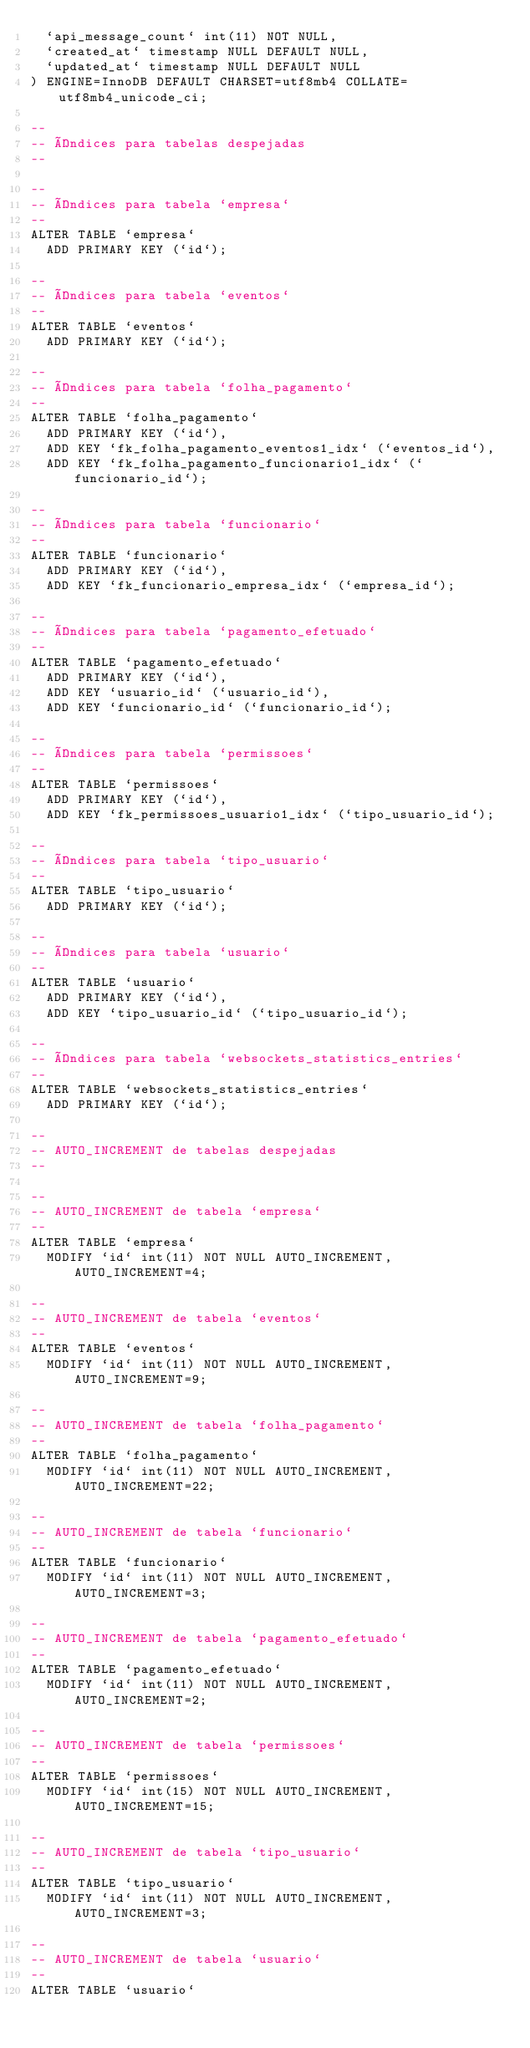<code> <loc_0><loc_0><loc_500><loc_500><_SQL_>  `api_message_count` int(11) NOT NULL,
  `created_at` timestamp NULL DEFAULT NULL,
  `updated_at` timestamp NULL DEFAULT NULL
) ENGINE=InnoDB DEFAULT CHARSET=utf8mb4 COLLATE=utf8mb4_unicode_ci;

--
-- Índices para tabelas despejadas
--

--
-- Índices para tabela `empresa`
--
ALTER TABLE `empresa`
  ADD PRIMARY KEY (`id`);

--
-- Índices para tabela `eventos`
--
ALTER TABLE `eventos`
  ADD PRIMARY KEY (`id`);

--
-- Índices para tabela `folha_pagamento`
--
ALTER TABLE `folha_pagamento`
  ADD PRIMARY KEY (`id`),
  ADD KEY `fk_folha_pagamento_eventos1_idx` (`eventos_id`),
  ADD KEY `fk_folha_pagamento_funcionario1_idx` (`funcionario_id`);

--
-- Índices para tabela `funcionario`
--
ALTER TABLE `funcionario`
  ADD PRIMARY KEY (`id`),
  ADD KEY `fk_funcionario_empresa_idx` (`empresa_id`);

--
-- Índices para tabela `pagamento_efetuado`
--
ALTER TABLE `pagamento_efetuado`
  ADD PRIMARY KEY (`id`),
  ADD KEY `usuario_id` (`usuario_id`),
  ADD KEY `funcionario_id` (`funcionario_id`);

--
-- Índices para tabela `permissoes`
--
ALTER TABLE `permissoes`
  ADD PRIMARY KEY (`id`),
  ADD KEY `fk_permissoes_usuario1_idx` (`tipo_usuario_id`);

--
-- Índices para tabela `tipo_usuario`
--
ALTER TABLE `tipo_usuario`
  ADD PRIMARY KEY (`id`);

--
-- Índices para tabela `usuario`
--
ALTER TABLE `usuario`
  ADD PRIMARY KEY (`id`),
  ADD KEY `tipo_usuario_id` (`tipo_usuario_id`);

--
-- Índices para tabela `websockets_statistics_entries`
--
ALTER TABLE `websockets_statistics_entries`
  ADD PRIMARY KEY (`id`);

--
-- AUTO_INCREMENT de tabelas despejadas
--

--
-- AUTO_INCREMENT de tabela `empresa`
--
ALTER TABLE `empresa`
  MODIFY `id` int(11) NOT NULL AUTO_INCREMENT, AUTO_INCREMENT=4;

--
-- AUTO_INCREMENT de tabela `eventos`
--
ALTER TABLE `eventos`
  MODIFY `id` int(11) NOT NULL AUTO_INCREMENT, AUTO_INCREMENT=9;

--
-- AUTO_INCREMENT de tabela `folha_pagamento`
--
ALTER TABLE `folha_pagamento`
  MODIFY `id` int(11) NOT NULL AUTO_INCREMENT, AUTO_INCREMENT=22;

--
-- AUTO_INCREMENT de tabela `funcionario`
--
ALTER TABLE `funcionario`
  MODIFY `id` int(11) NOT NULL AUTO_INCREMENT, AUTO_INCREMENT=3;

--
-- AUTO_INCREMENT de tabela `pagamento_efetuado`
--
ALTER TABLE `pagamento_efetuado`
  MODIFY `id` int(11) NOT NULL AUTO_INCREMENT, AUTO_INCREMENT=2;

--
-- AUTO_INCREMENT de tabela `permissoes`
--
ALTER TABLE `permissoes`
  MODIFY `id` int(15) NOT NULL AUTO_INCREMENT, AUTO_INCREMENT=15;

--
-- AUTO_INCREMENT de tabela `tipo_usuario`
--
ALTER TABLE `tipo_usuario`
  MODIFY `id` int(11) NOT NULL AUTO_INCREMENT, AUTO_INCREMENT=3;

--
-- AUTO_INCREMENT de tabela `usuario`
--
ALTER TABLE `usuario`</code> 